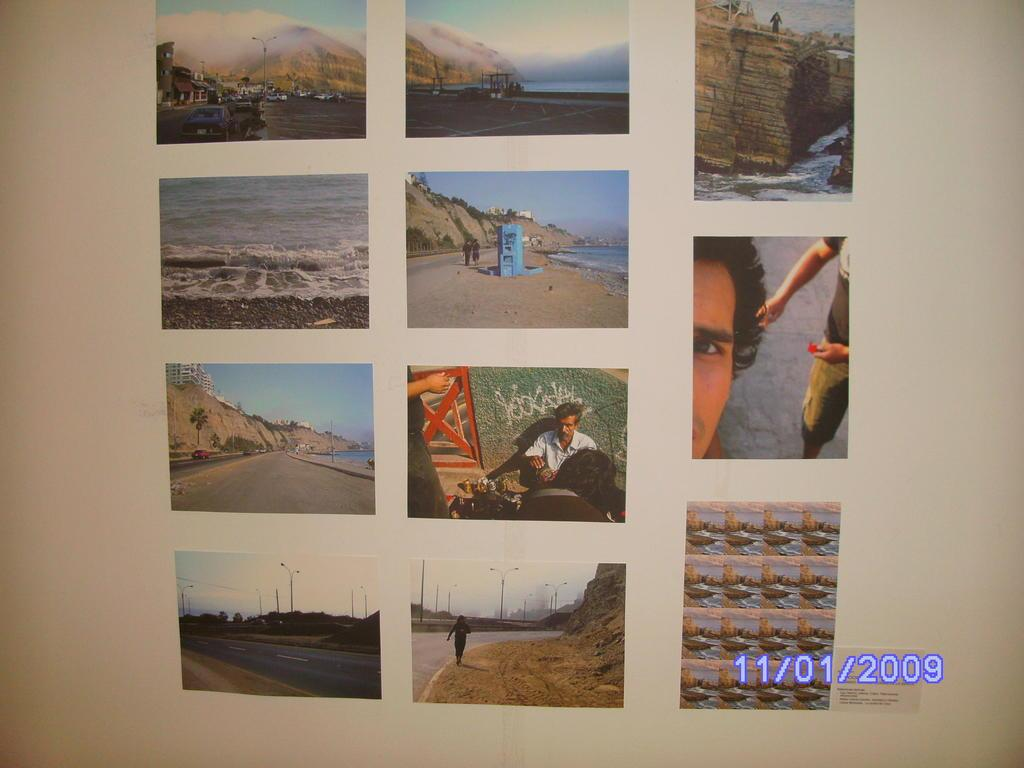What is the main subject of the pictures in the image? The pictures on the white surface in the image contain people, mountains, and roads. Can you describe any additional features of the image? There is a watermark at the bottom of the image. What verse is being recited by the people in the pictures? There is no indication in the image that the people are reciting a verse or poem. 